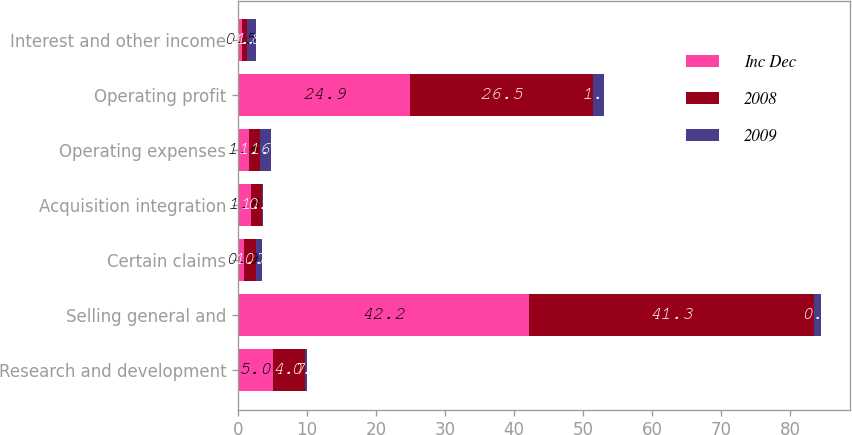Convert chart. <chart><loc_0><loc_0><loc_500><loc_500><stacked_bar_chart><ecel><fcel>Research and development<fcel>Selling general and<fcel>Certain claims<fcel>Acquisition integration<fcel>Operating expenses<fcel>Operating profit<fcel>Interest and other income<nl><fcel>Inc Dec<fcel>5<fcel>42.2<fcel>0.9<fcel>1.8<fcel>1.6<fcel>24.9<fcel>0.5<nl><fcel>2008<fcel>4.7<fcel>41.3<fcel>1.7<fcel>1.6<fcel>1.6<fcel>26.5<fcel>0.8<nl><fcel>2009<fcel>0.3<fcel>0.9<fcel>0.8<fcel>0.2<fcel>1.6<fcel>1.6<fcel>1.3<nl></chart> 